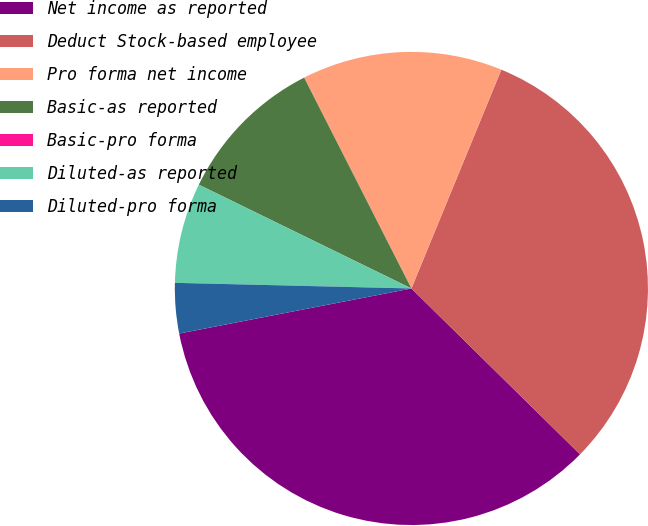Convert chart to OTSL. <chart><loc_0><loc_0><loc_500><loc_500><pie_chart><fcel>Net income as reported<fcel>Deduct Stock-based employee<fcel>Pro forma net income<fcel>Basic-as reported<fcel>Basic-pro forma<fcel>Diluted-as reported<fcel>Diluted-pro forma<nl><fcel>34.58%<fcel>31.16%<fcel>13.7%<fcel>10.28%<fcel>0.0%<fcel>6.85%<fcel>3.43%<nl></chart> 